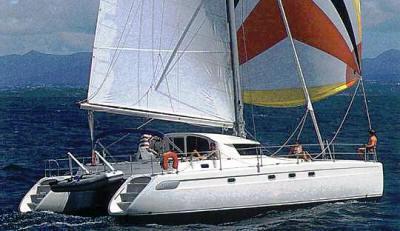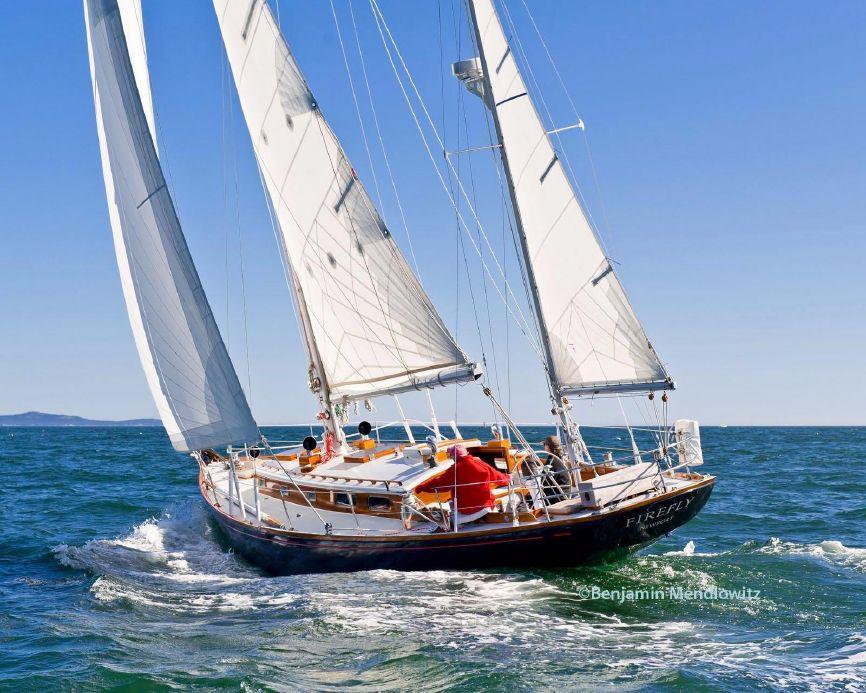The first image is the image on the left, the second image is the image on the right. For the images displayed, is the sentence "The sails are furled in the image on the left." factually correct? Answer yes or no. No. 